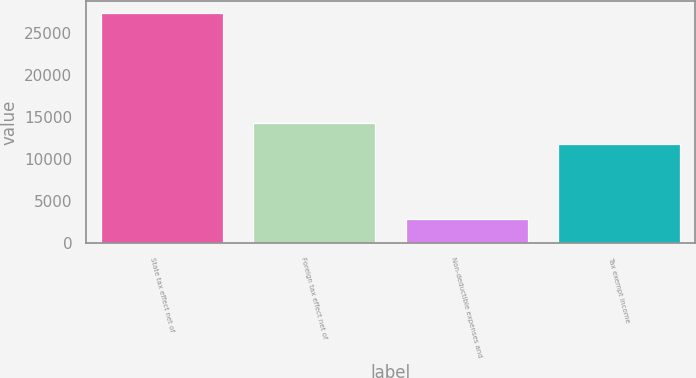Convert chart to OTSL. <chart><loc_0><loc_0><loc_500><loc_500><bar_chart><fcel>State tax effect net of<fcel>Foreign tax effect net of<fcel>Non-deductible expenses and<fcel>Tax exempt income<nl><fcel>27359<fcel>14271.1<fcel>2918<fcel>11827<nl></chart> 